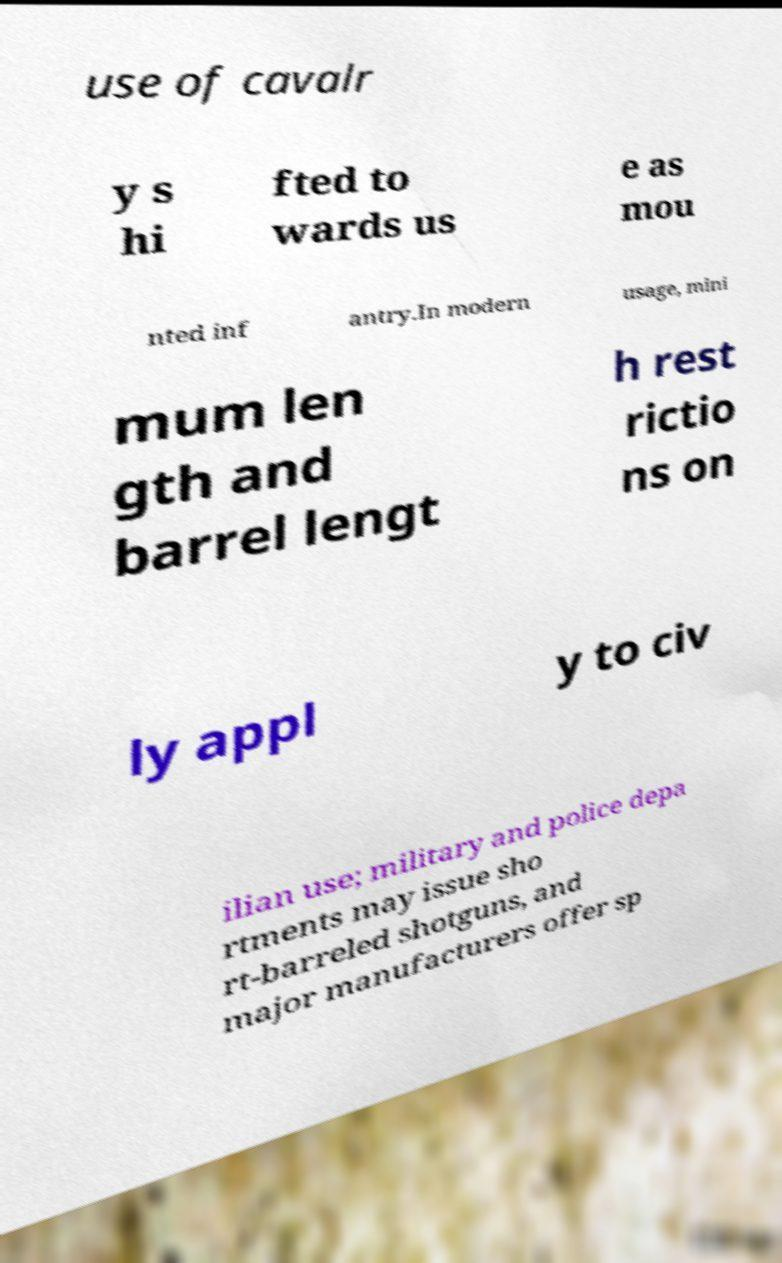Please identify and transcribe the text found in this image. use of cavalr y s hi fted to wards us e as mou nted inf antry.In modern usage, mini mum len gth and barrel lengt h rest rictio ns on ly appl y to civ ilian use; military and police depa rtments may issue sho rt-barreled shotguns, and major manufacturers offer sp 